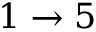<formula> <loc_0><loc_0><loc_500><loc_500>1 \to 5</formula> 